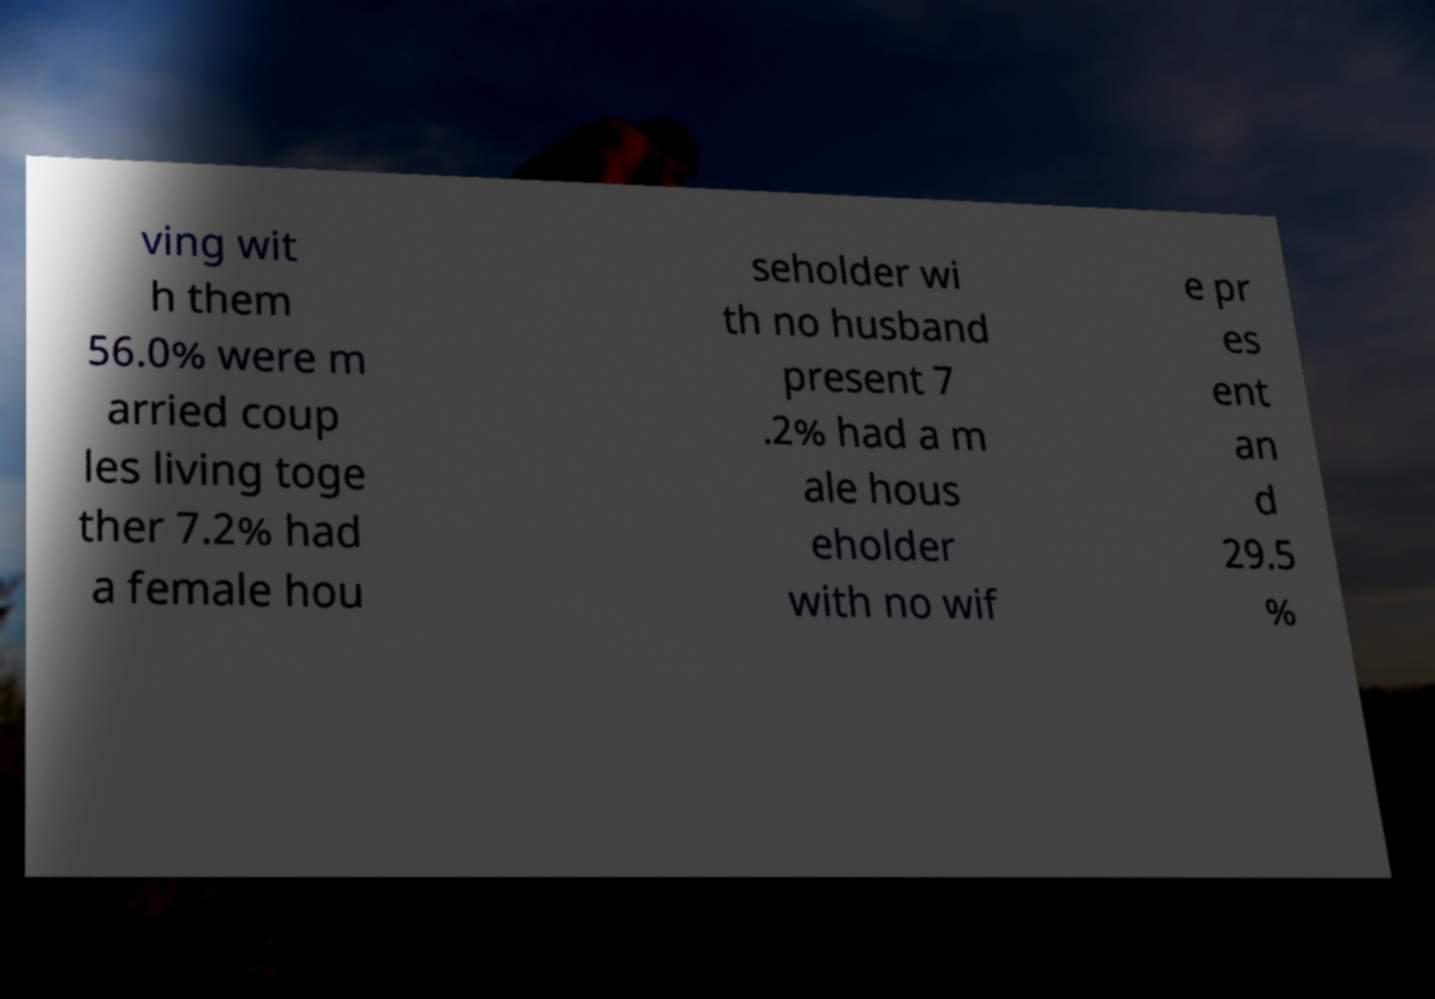Please read and relay the text visible in this image. What does it say? ving wit h them 56.0% were m arried coup les living toge ther 7.2% had a female hou seholder wi th no husband present 7 .2% had a m ale hous eholder with no wif e pr es ent an d 29.5 % 